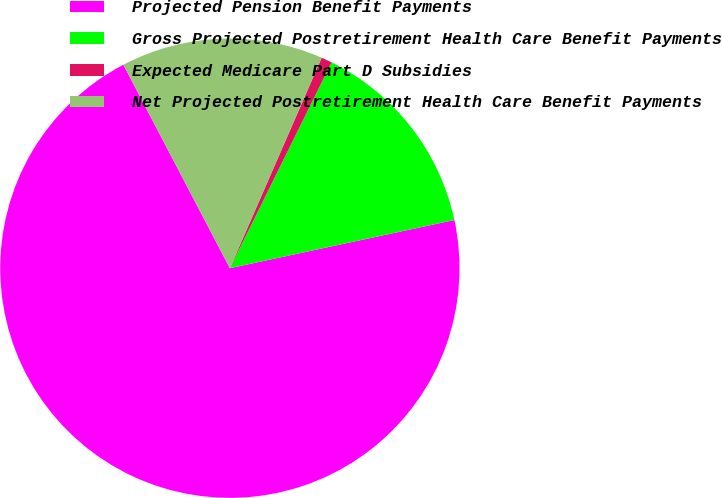<chart> <loc_0><loc_0><loc_500><loc_500><pie_chart><fcel>Projected Pension Benefit Payments<fcel>Gross Projected Postretirement Health Care Benefit Payments<fcel>Expected Medicare Part D Subsidies<fcel>Net Projected Postretirement Health Care Benefit Payments<nl><fcel>70.7%<fcel>14.33%<fcel>0.76%<fcel>14.22%<nl></chart> 